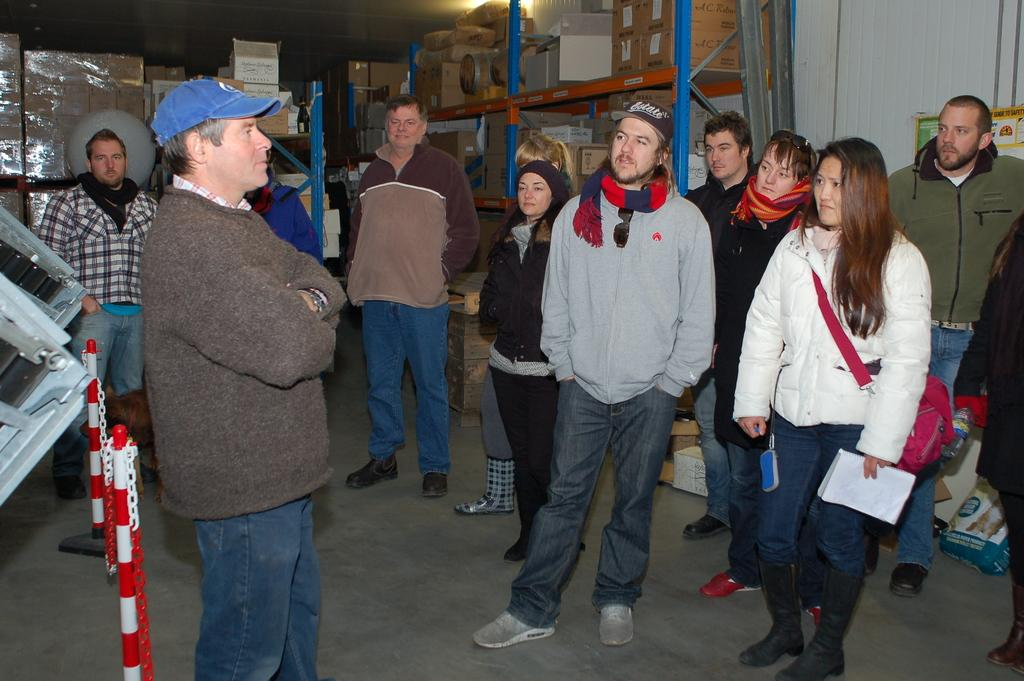What are the people in the image doing? There is a group of people standing on the floor. Can you describe the attire of some of the people? Some people are wearing caps. What items can be seen in the image besides the people? There are bags, books, poles, chains, boxes in racks, and posters on the wall. What type of objects are in the racks? The objects in the racks are boxes. What is on the wall in the image? There are posters on the wall. What is the group of people reading in the image? There is no indication in the image that the group of people is reading; they are simply standing on the floor. What type of library is depicted in the image? There is no library present in the image; it contains a group of people, various objects, and posters on the wall. 